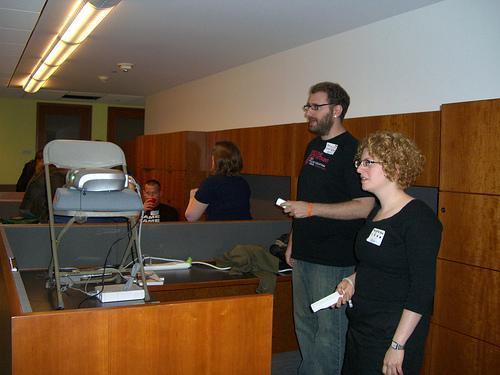How many people are wearing glasses?
Give a very brief answer. 2. 